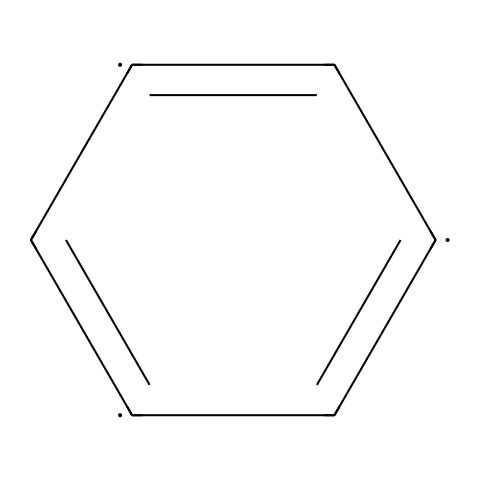What is the total number of carbon atoms in the chemical structure? The SMILES representation indicates that there are six carbon atoms represented by the letter "C" repeated six times.
Answer: six How many double bonds are present in the structure? The SMILES notation includes alternating double bonds, which can be counted by observing the "=" signs; there are three double bonds in total.
Answer: three What type of hybridization do the carbon atoms in this structure exhibit? The carbon atoms in graphene are sp2 hybridized, as indicated by the planar structure and the presence of double bonds.
Answer: sp2 What is the primary structural feature of graphene that contributes to its strength? The extensive network of carbon-carbon bonds (specifically the sp2 bonds), creates a strong two-dimensional honeycomb lattice that contributes to graphene's high strength.
Answer: honeycomb lattice Can this structure be classified as a 2D material? Yes, the chemical structure represents a two-dimensional arrangement of carbon atoms, characteristic of graphene, making it a 2D material.
Answer: yes How many resonance structures can be drawn for this compound? The alternating double bonds indicate that there are multiple resonance structures possible; for this compound, three resonance structures can be drawn.
Answer: three What is the main application of materials derived from this structure? Materials derived from graphene are primarily used in applications requiring lightweight and high-strength properties, such as electronics and composites.
Answer: electronics 